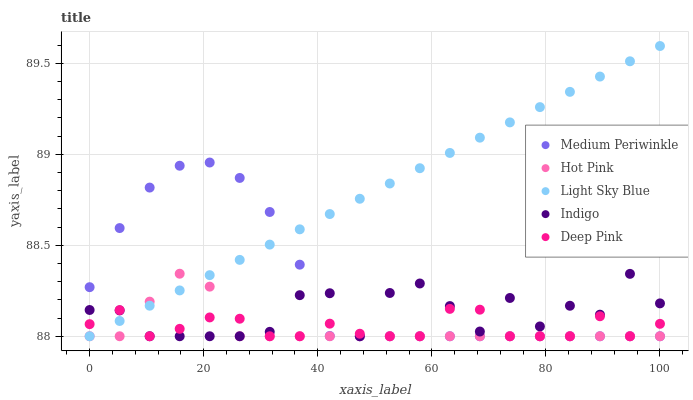Does Hot Pink have the minimum area under the curve?
Answer yes or no. Yes. Does Light Sky Blue have the maximum area under the curve?
Answer yes or no. Yes. Does Medium Periwinkle have the minimum area under the curve?
Answer yes or no. No. Does Medium Periwinkle have the maximum area under the curve?
Answer yes or no. No. Is Light Sky Blue the smoothest?
Answer yes or no. Yes. Is Indigo the roughest?
Answer yes or no. Yes. Is Hot Pink the smoothest?
Answer yes or no. No. Is Hot Pink the roughest?
Answer yes or no. No. Does Indigo have the lowest value?
Answer yes or no. Yes. Does Light Sky Blue have the highest value?
Answer yes or no. Yes. Does Hot Pink have the highest value?
Answer yes or no. No. Does Medium Periwinkle intersect Hot Pink?
Answer yes or no. Yes. Is Medium Periwinkle less than Hot Pink?
Answer yes or no. No. Is Medium Periwinkle greater than Hot Pink?
Answer yes or no. No. 